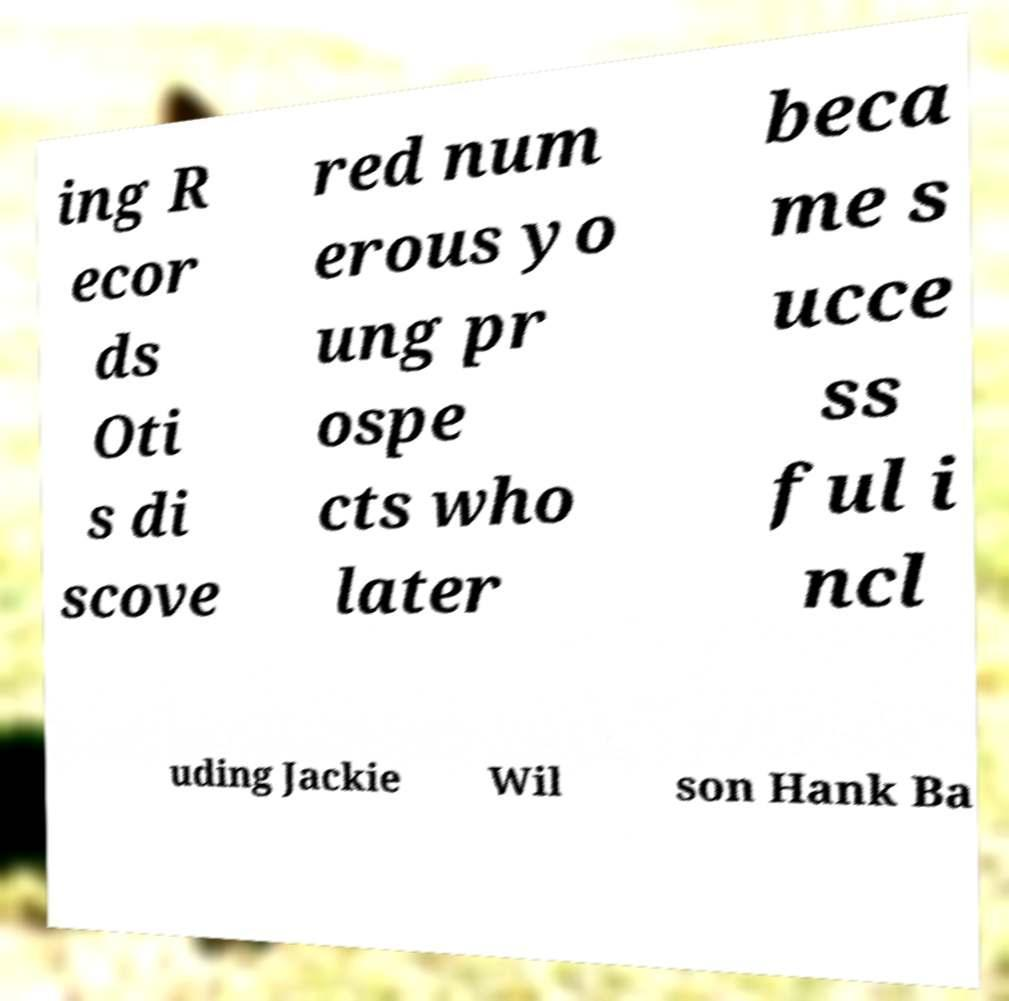Can you accurately transcribe the text from the provided image for me? ing R ecor ds Oti s di scove red num erous yo ung pr ospe cts who later beca me s ucce ss ful i ncl uding Jackie Wil son Hank Ba 